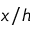<formula> <loc_0><loc_0><loc_500><loc_500>x / h</formula> 